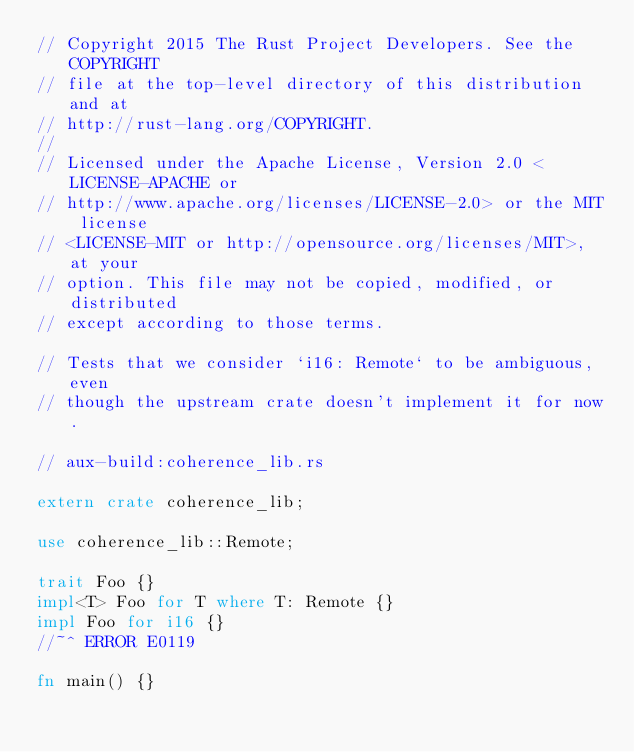Convert code to text. <code><loc_0><loc_0><loc_500><loc_500><_Rust_>// Copyright 2015 The Rust Project Developers. See the COPYRIGHT
// file at the top-level directory of this distribution and at
// http://rust-lang.org/COPYRIGHT.
//
// Licensed under the Apache License, Version 2.0 <LICENSE-APACHE or
// http://www.apache.org/licenses/LICENSE-2.0> or the MIT license
// <LICENSE-MIT or http://opensource.org/licenses/MIT>, at your
// option. This file may not be copied, modified, or distributed
// except according to those terms.

// Tests that we consider `i16: Remote` to be ambiguous, even
// though the upstream crate doesn't implement it for now.

// aux-build:coherence_lib.rs

extern crate coherence_lib;

use coherence_lib::Remote;

trait Foo {}
impl<T> Foo for T where T: Remote {}
impl Foo for i16 {}
//~^ ERROR E0119

fn main() {}
</code> 